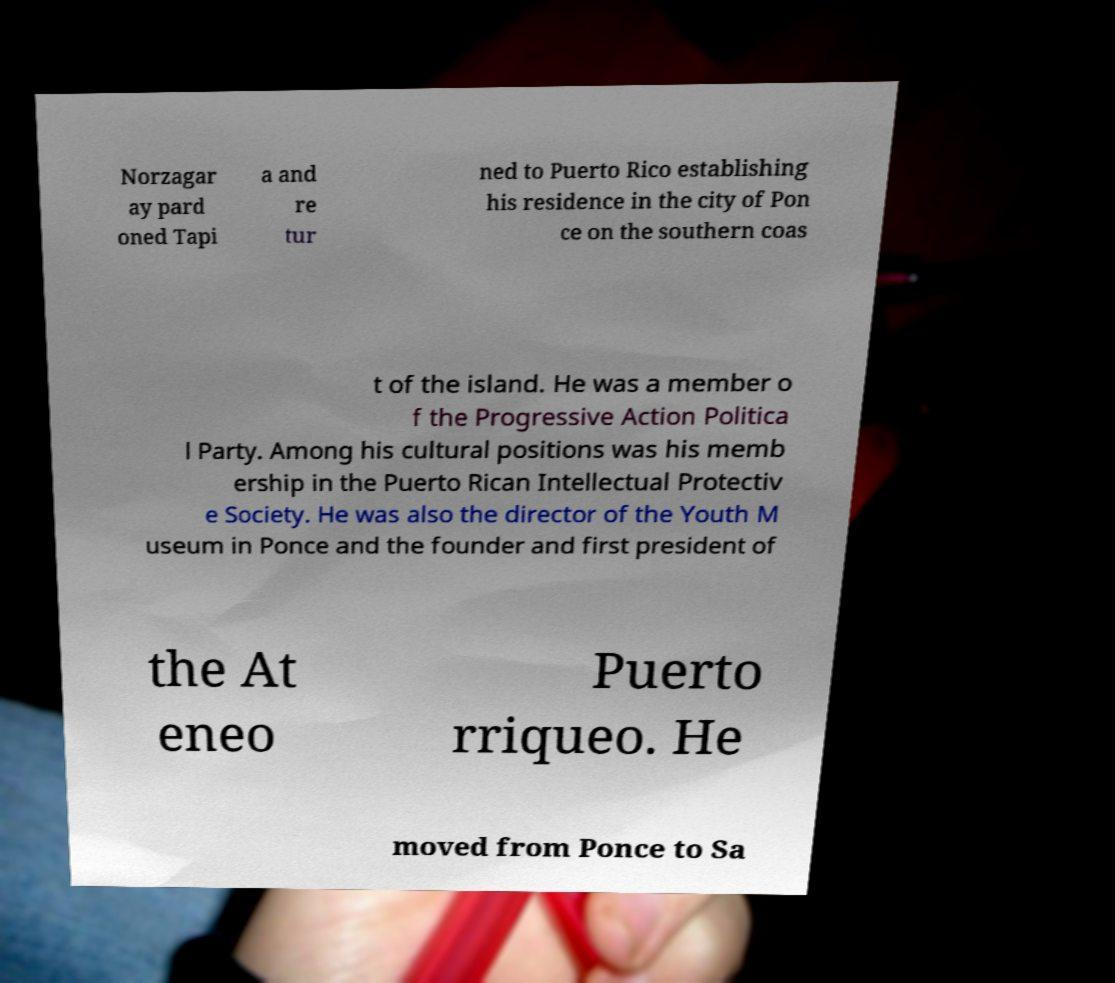Can you read and provide the text displayed in the image?This photo seems to have some interesting text. Can you extract and type it out for me? Norzagar ay pard oned Tapi a and re tur ned to Puerto Rico establishing his residence in the city of Pon ce on the southern coas t of the island. He was a member o f the Progressive Action Politica l Party. Among his cultural positions was his memb ership in the Puerto Rican Intellectual Protectiv e Society. He was also the director of the Youth M useum in Ponce and the founder and first president of the At eneo Puerto rriqueo. He moved from Ponce to Sa 